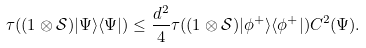Convert formula to latex. <formula><loc_0><loc_0><loc_500><loc_500>\tau ( ( { 1 } \otimes \mathcal { S } ) | \Psi \rangle \langle \Psi | ) \leq \frac { d ^ { 2 } } { 4 } \tau ( ( { 1 } \otimes \mathcal { S } ) | \phi ^ { + } \rangle \langle \phi ^ { + } | ) C ^ { 2 } ( \Psi ) .</formula> 